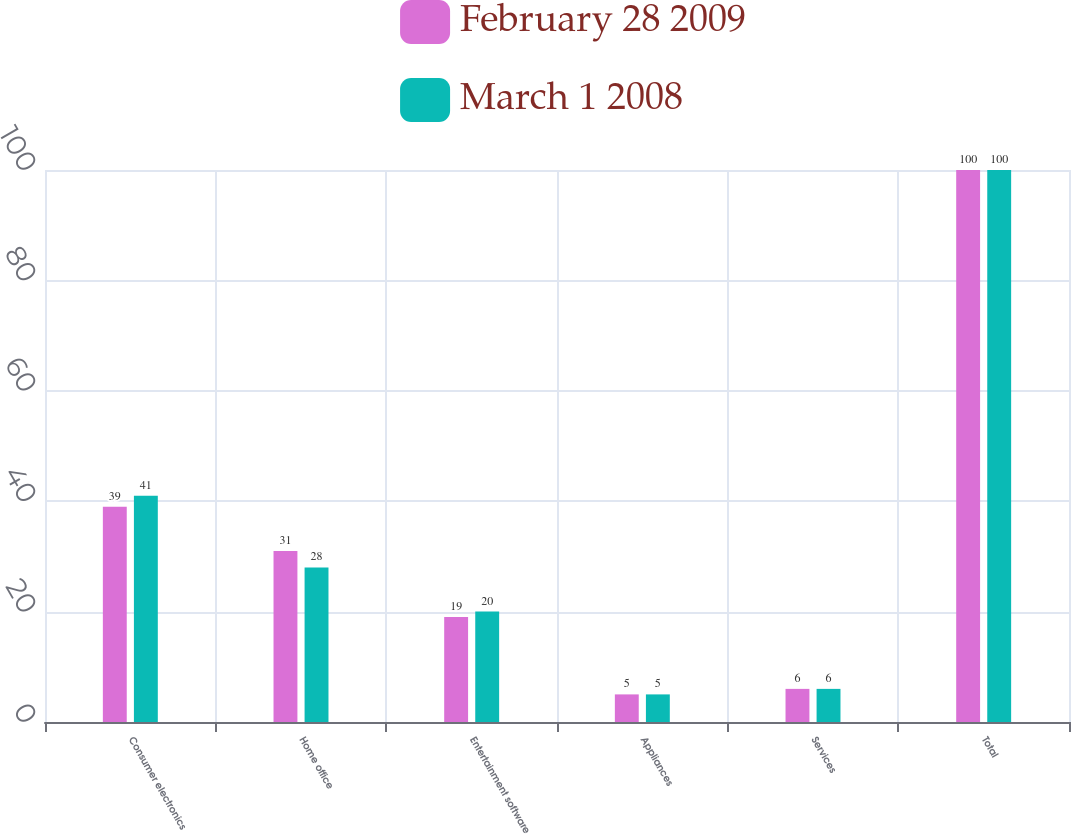Convert chart to OTSL. <chart><loc_0><loc_0><loc_500><loc_500><stacked_bar_chart><ecel><fcel>Consumer electronics<fcel>Home office<fcel>Entertainment software<fcel>Appliances<fcel>Services<fcel>Total<nl><fcel>February 28 2009<fcel>39<fcel>31<fcel>19<fcel>5<fcel>6<fcel>100<nl><fcel>March 1 2008<fcel>41<fcel>28<fcel>20<fcel>5<fcel>6<fcel>100<nl></chart> 